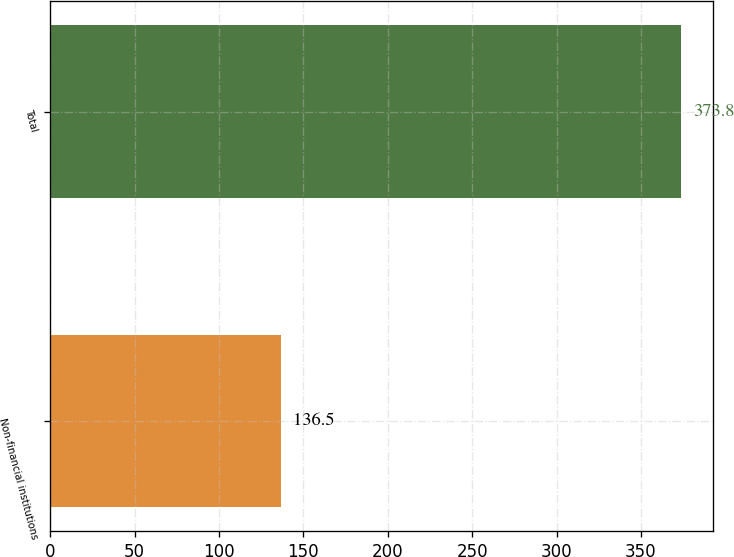<chart> <loc_0><loc_0><loc_500><loc_500><bar_chart><fcel>Non-financial institutions<fcel>Total<nl><fcel>136.5<fcel>373.8<nl></chart> 